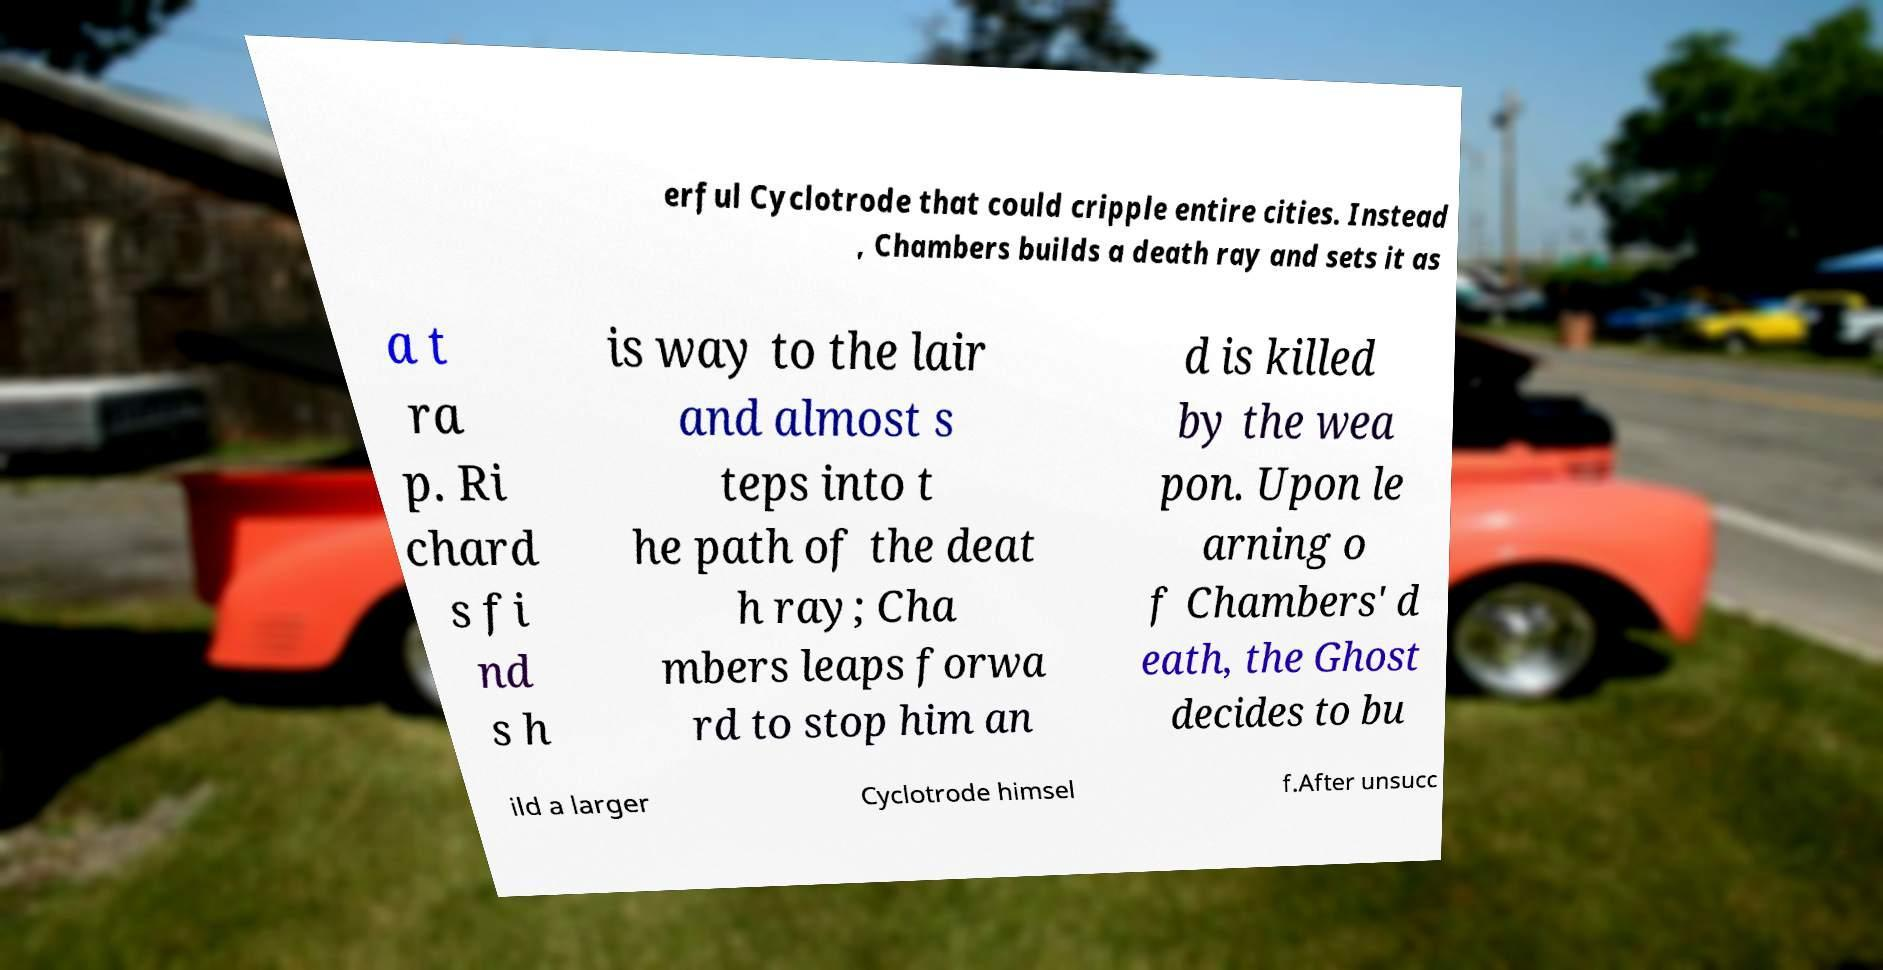Can you read and provide the text displayed in the image?This photo seems to have some interesting text. Can you extract and type it out for me? erful Cyclotrode that could cripple entire cities. Instead , Chambers builds a death ray and sets it as a t ra p. Ri chard s fi nd s h is way to the lair and almost s teps into t he path of the deat h ray; Cha mbers leaps forwa rd to stop him an d is killed by the wea pon. Upon le arning o f Chambers' d eath, the Ghost decides to bu ild a larger Cyclotrode himsel f.After unsucc 